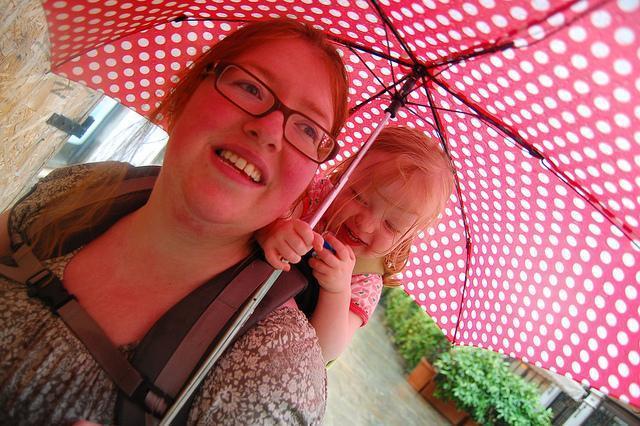How many people are shown?
Give a very brief answer. 2. How many people are there?
Give a very brief answer. 2. 